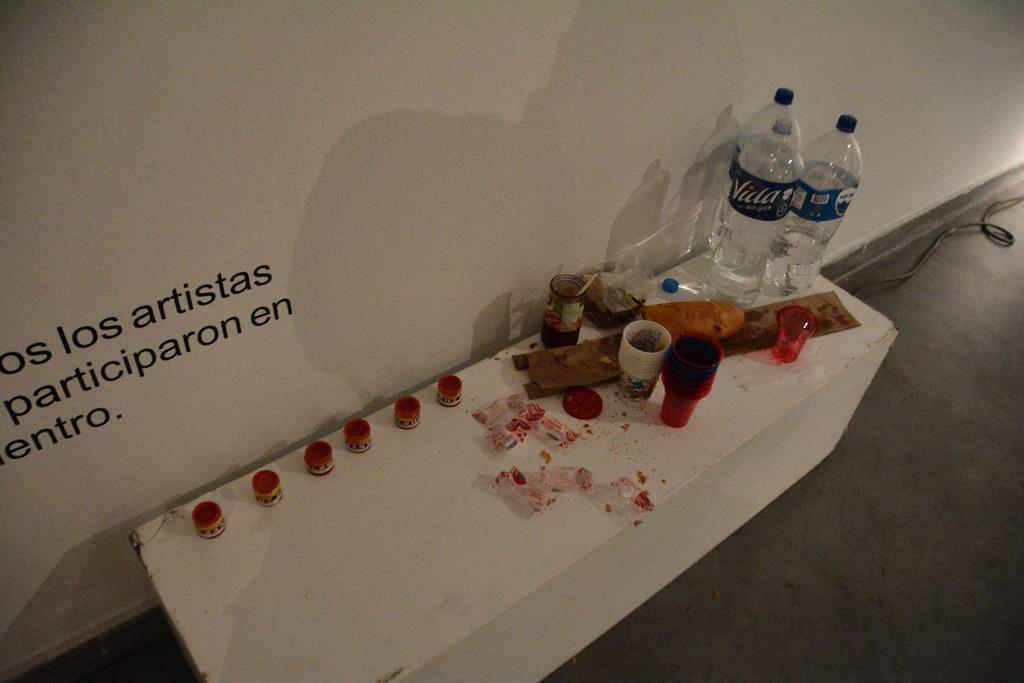What is on the floor in the image? There is a table on the floor in the image. What can be seen on the table? There are glasses and water bottles on the table, as well as other objects. What is on the wall in the image? There is writing on the wall in the image. Can you see a toad sitting on the table in the image? No, there is no toad present in the image. What type of oil is being used in the image? There is no oil present in the image. 